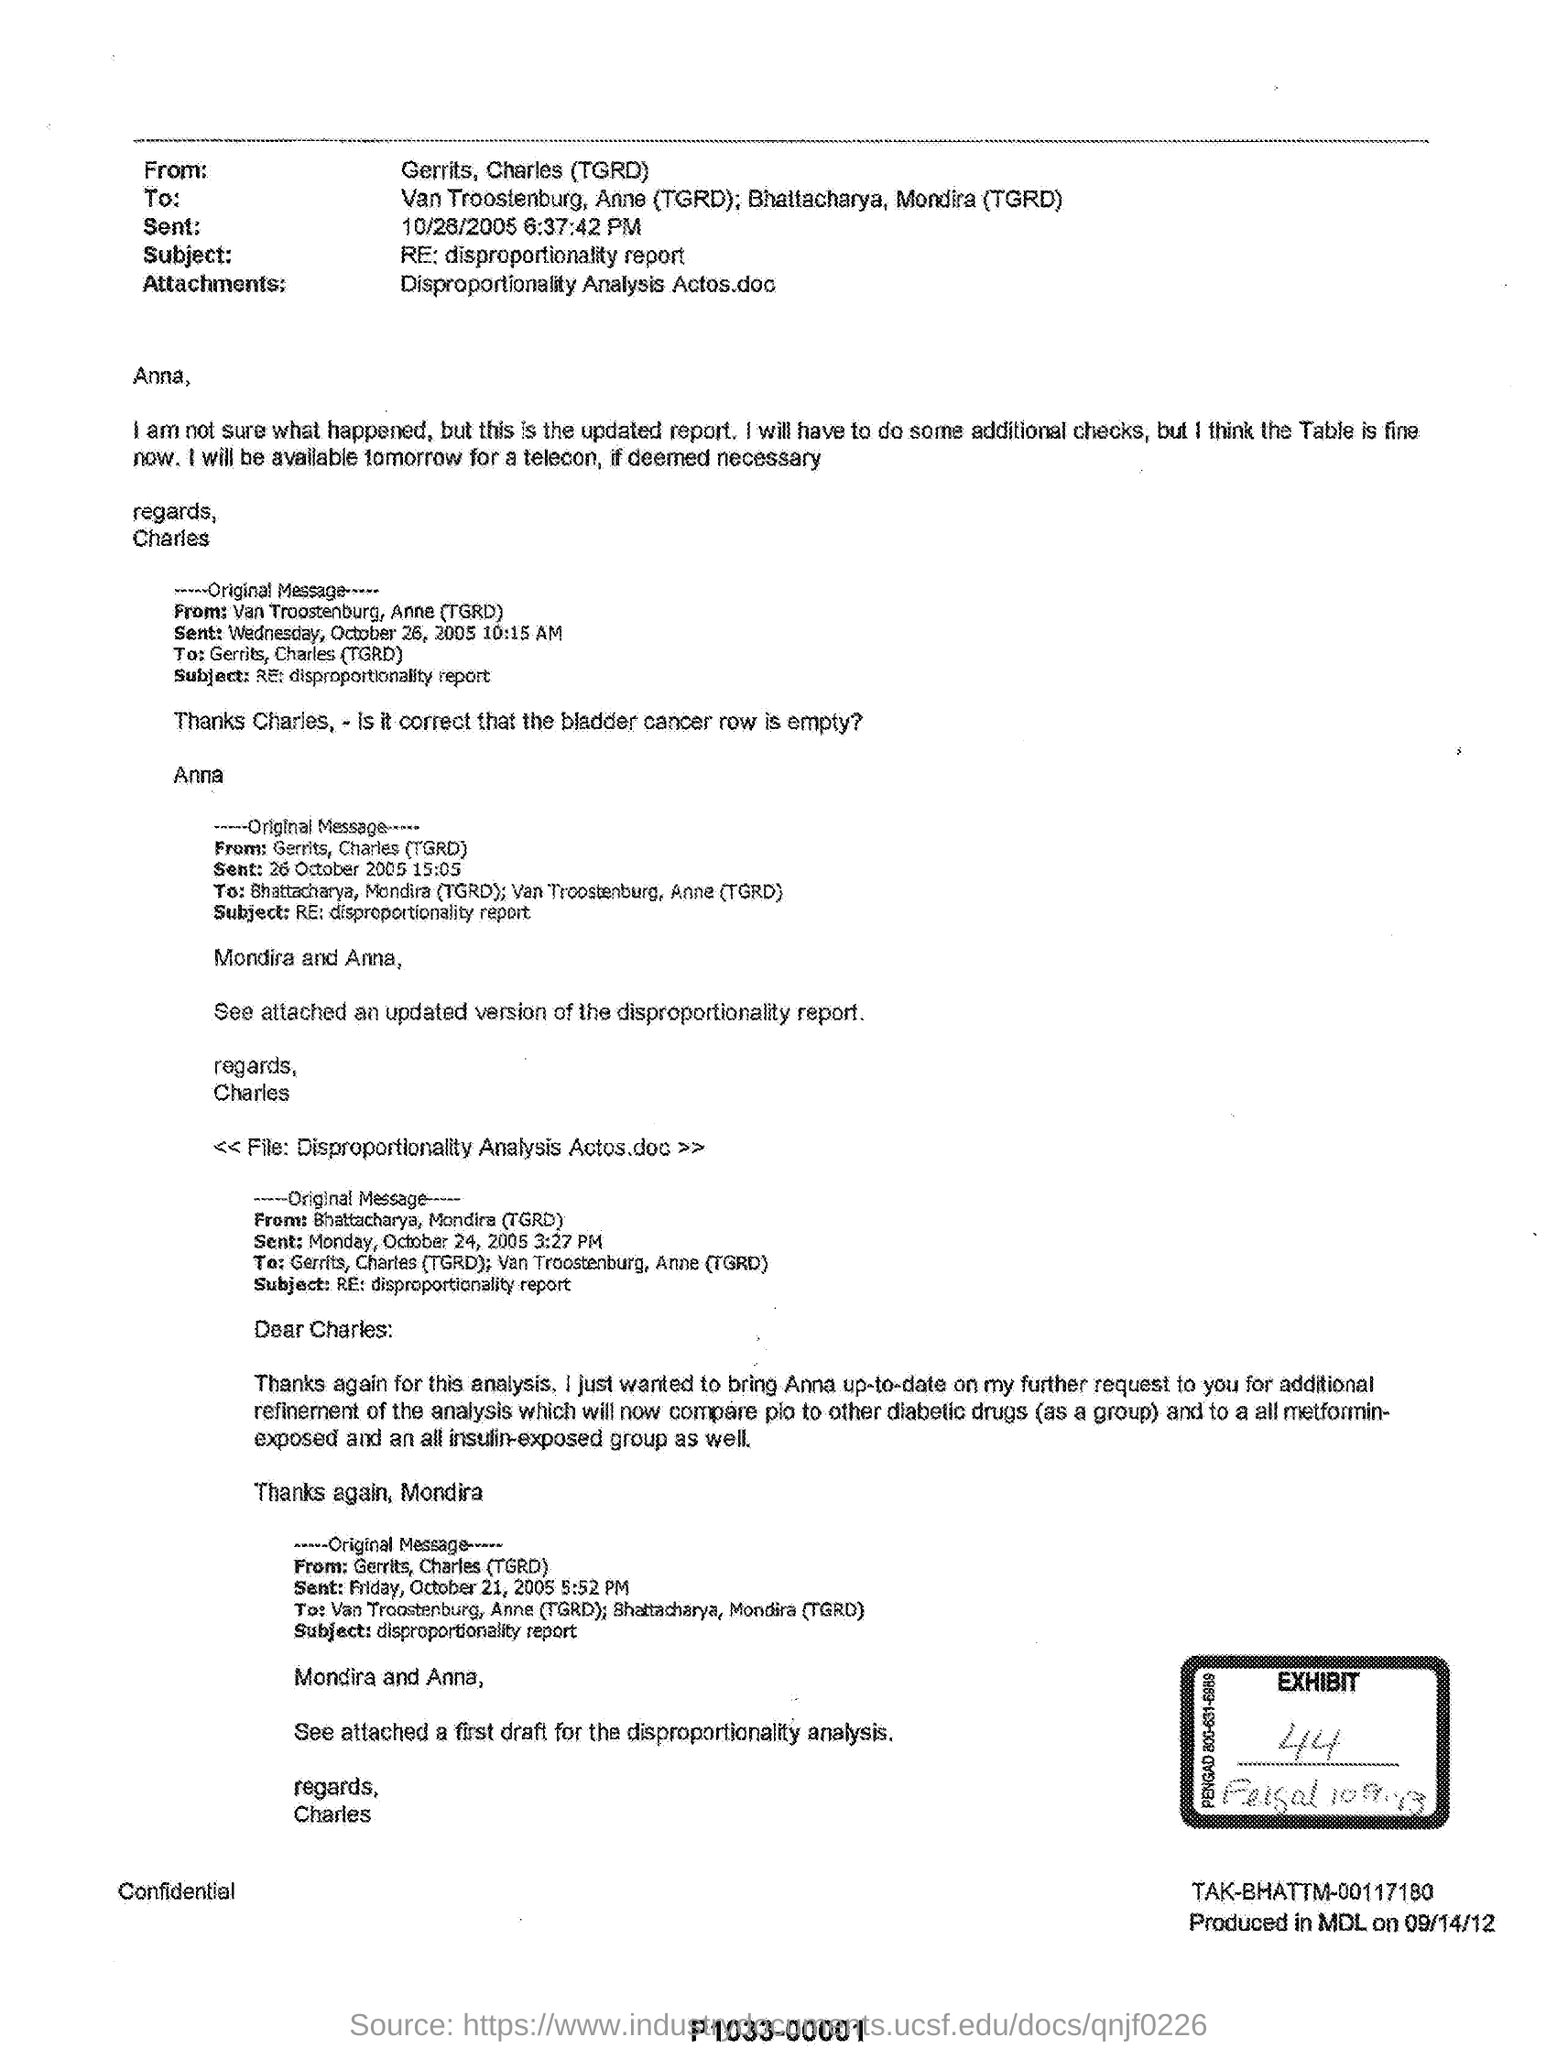List a handful of essential elements in this visual. The attached disproportionality report is the updated version. The subject mentions a report called the "disproportionality report". I will be available for a teleconference tomorrow if necessary. 